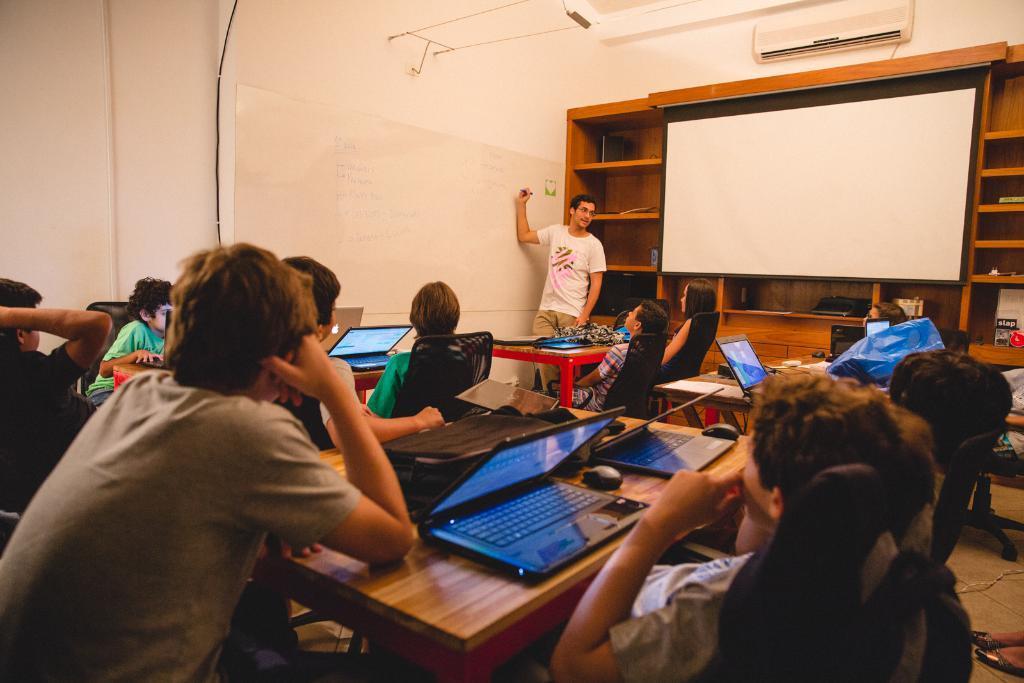In one or two sentences, can you explain what this image depicts? This picture consists of table , on the table I can see laptop and around the table some persons sitting on chairs and I can see a person wearing a white color t-shirt standing in front of the board and I can see a rack , in front of rack I can see a board and I can see the wall and I can see ac attached to the wall. 